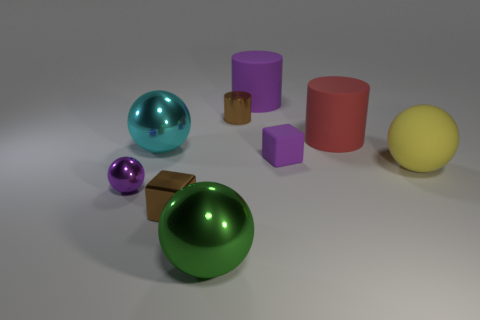Add 1 big red things. How many objects exist? 10 Subtract all cylinders. How many objects are left? 6 Add 6 big cyan metal things. How many big cyan metal things are left? 7 Add 9 large yellow rubber balls. How many large yellow rubber balls exist? 10 Subtract 1 brown blocks. How many objects are left? 8 Subtract all large rubber objects. Subtract all big shiny spheres. How many objects are left? 4 